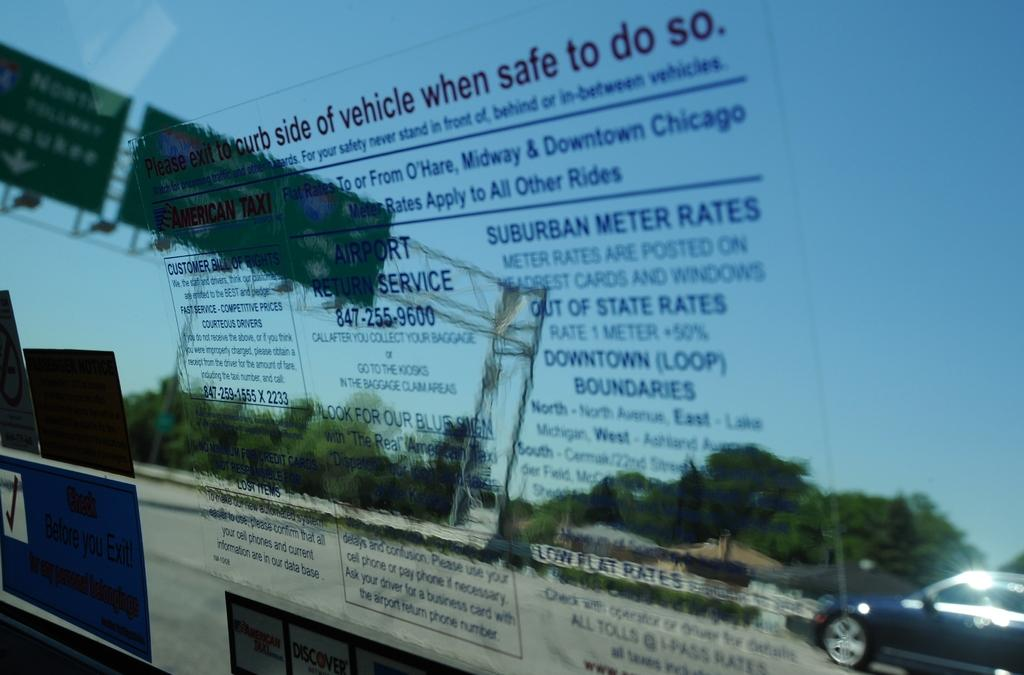What is on the glass in the image? There is a poster on the glass. What can be seen through the glass? Trees, vehicles, a road, rods, boards, and the sky are visible through the glass. What type of structures are the rods in the image? The rods in the image are likely utility poles or similar structures. What type of signs or advertisements are the boards in the image? The boards in the image are likely signs or advertisements. Where is the love scene taking place in the image? There is no love scene present in the image; it primarily features a poster on the glass and various elements visible through the glass. 